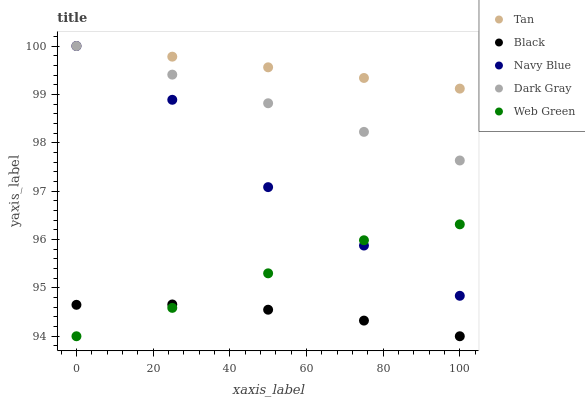Does Black have the minimum area under the curve?
Answer yes or no. Yes. Does Tan have the maximum area under the curve?
Answer yes or no. Yes. Does Navy Blue have the minimum area under the curve?
Answer yes or no. No. Does Navy Blue have the maximum area under the curve?
Answer yes or no. No. Is Tan the smoothest?
Answer yes or no. Yes. Is Navy Blue the roughest?
Answer yes or no. Yes. Is Navy Blue the smoothest?
Answer yes or no. No. Is Tan the roughest?
Answer yes or no. No. Does Black have the lowest value?
Answer yes or no. Yes. Does Navy Blue have the lowest value?
Answer yes or no. No. Does Tan have the highest value?
Answer yes or no. Yes. Does Black have the highest value?
Answer yes or no. No. Is Web Green less than Dark Gray?
Answer yes or no. Yes. Is Navy Blue greater than Black?
Answer yes or no. Yes. Does Web Green intersect Black?
Answer yes or no. Yes. Is Web Green less than Black?
Answer yes or no. No. Is Web Green greater than Black?
Answer yes or no. No. Does Web Green intersect Dark Gray?
Answer yes or no. No. 